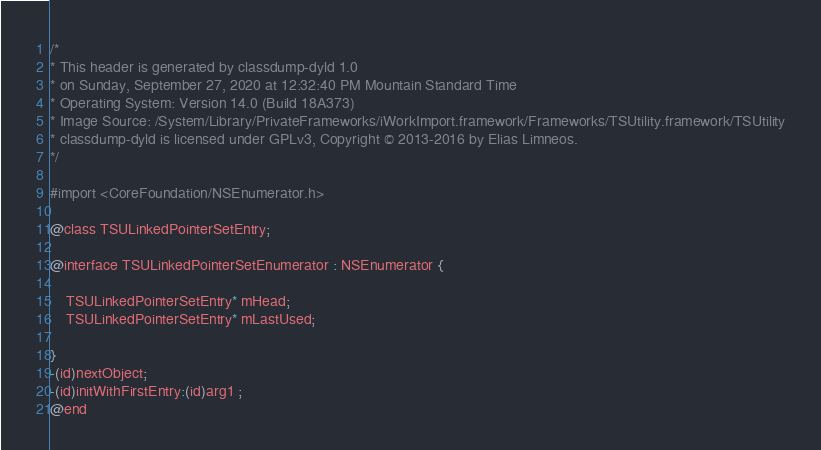Convert code to text. <code><loc_0><loc_0><loc_500><loc_500><_C_>/*
* This header is generated by classdump-dyld 1.0
* on Sunday, September 27, 2020 at 12:32:40 PM Mountain Standard Time
* Operating System: Version 14.0 (Build 18A373)
* Image Source: /System/Library/PrivateFrameworks/iWorkImport.framework/Frameworks/TSUtility.framework/TSUtility
* classdump-dyld is licensed under GPLv3, Copyright © 2013-2016 by Elias Limneos.
*/

#import <CoreFoundation/NSEnumerator.h>

@class TSULinkedPointerSetEntry;

@interface TSULinkedPointerSetEnumerator : NSEnumerator {

	TSULinkedPointerSetEntry* mHead;
	TSULinkedPointerSetEntry* mLastUsed;

}
-(id)nextObject;
-(id)initWithFirstEntry:(id)arg1 ;
@end

</code> 